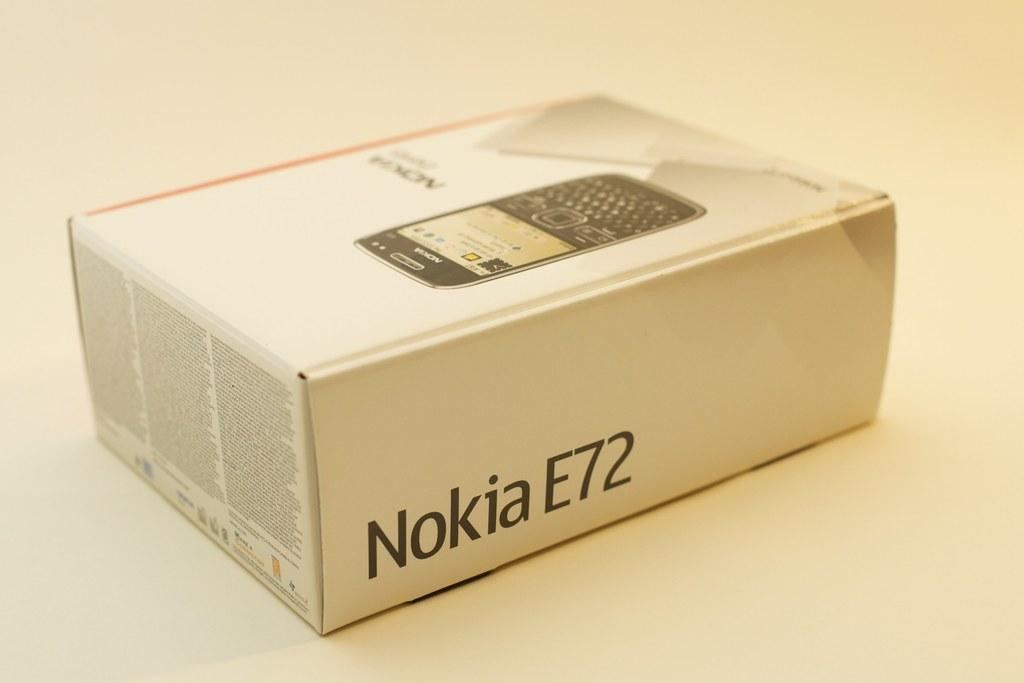<image>
Describe the image concisely. A box that says Nokia E72 on the side. 